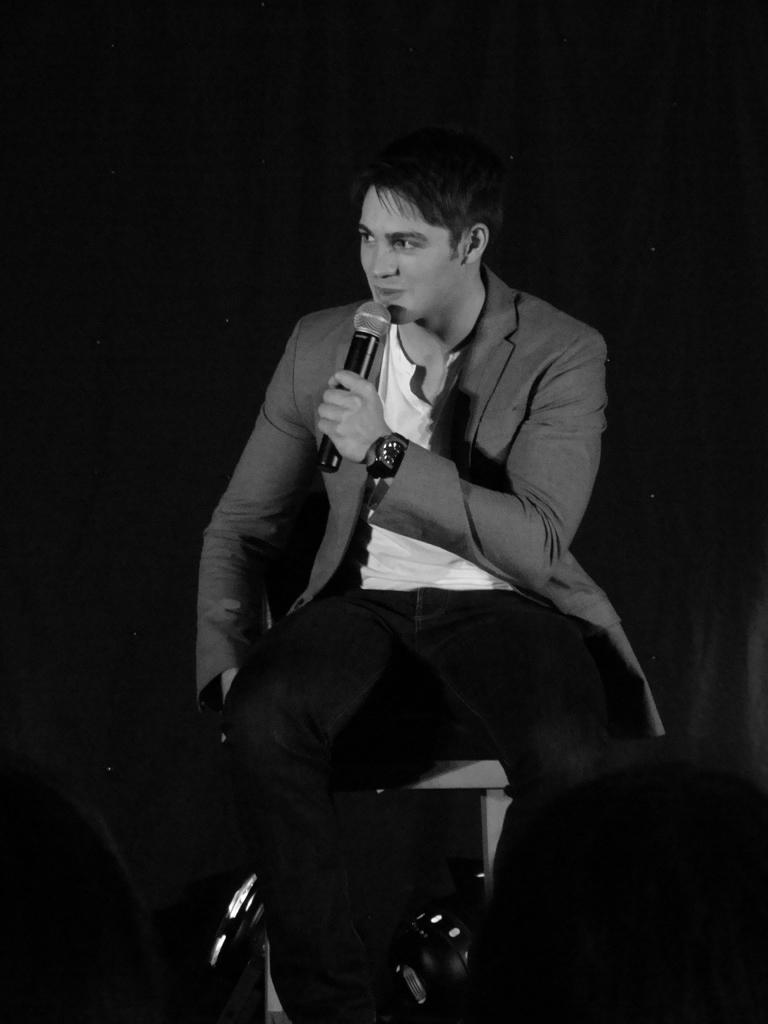What is the main subject of the image? The main subject of the image is a man sitting in the center of the image. What is the man holding in the image? The man is holding a microphone. What expression does the man have in the image? The man is smiling. What type of jelly can be seen on the sidewalk in the image? There is no jelly present on the sidewalk in the image. What type of selection process is being conducted in the image? There is no selection process depicted in the image; it features a man sitting and holding a microphone. 